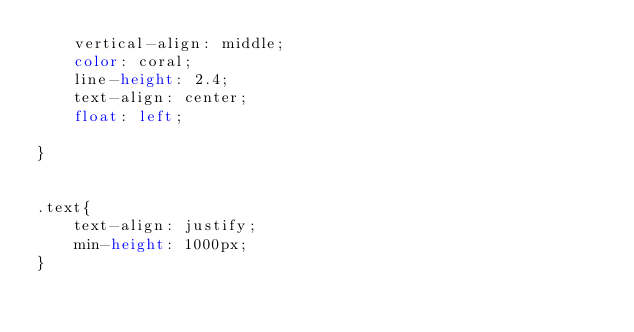Convert code to text. <code><loc_0><loc_0><loc_500><loc_500><_CSS_>    vertical-align: middle;
    color: coral;
    line-height: 2.4;
    text-align: center;       
    float: left;    
    
}


.text{
    text-align: justify;
    min-height: 1000px;
}</code> 